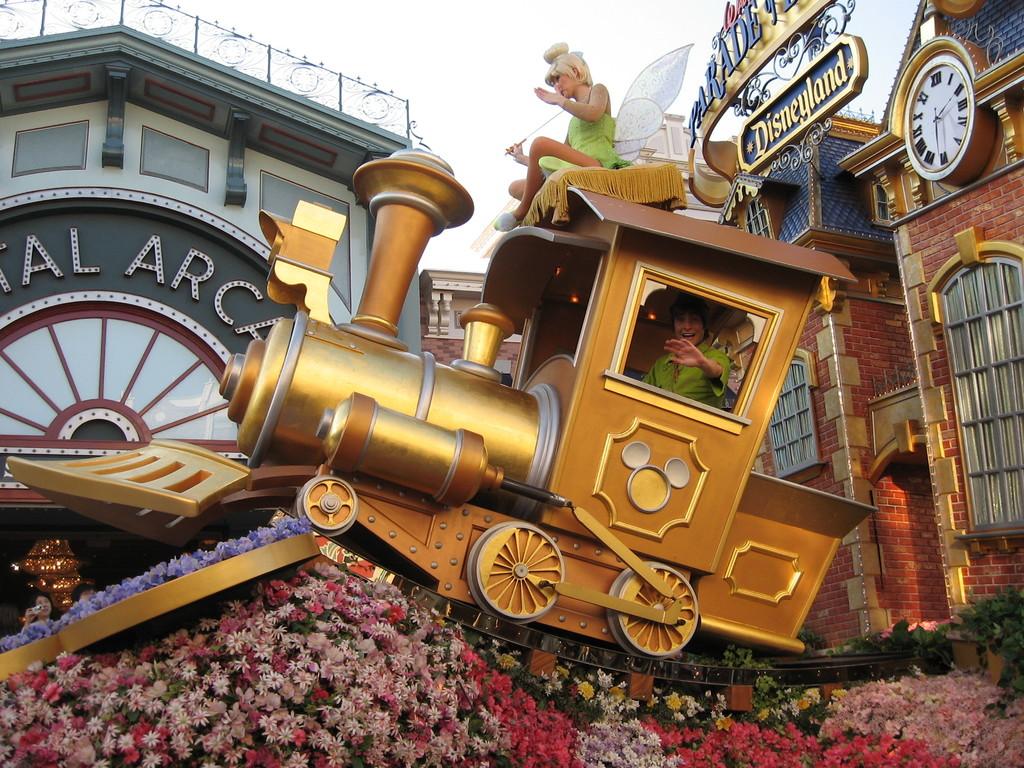What time does the clock read?
Provide a short and direct response. 2:30. 